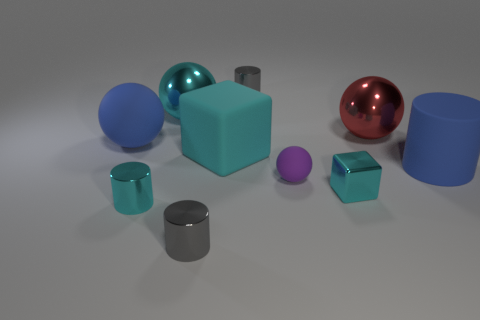How would you describe the textures of the objects? The surfaces of the objects appear smooth. The metallic spheres and cylinders have reflective surfaces, while the matte objects have a softer, light-absorbing texture, like plastic or rubber. 